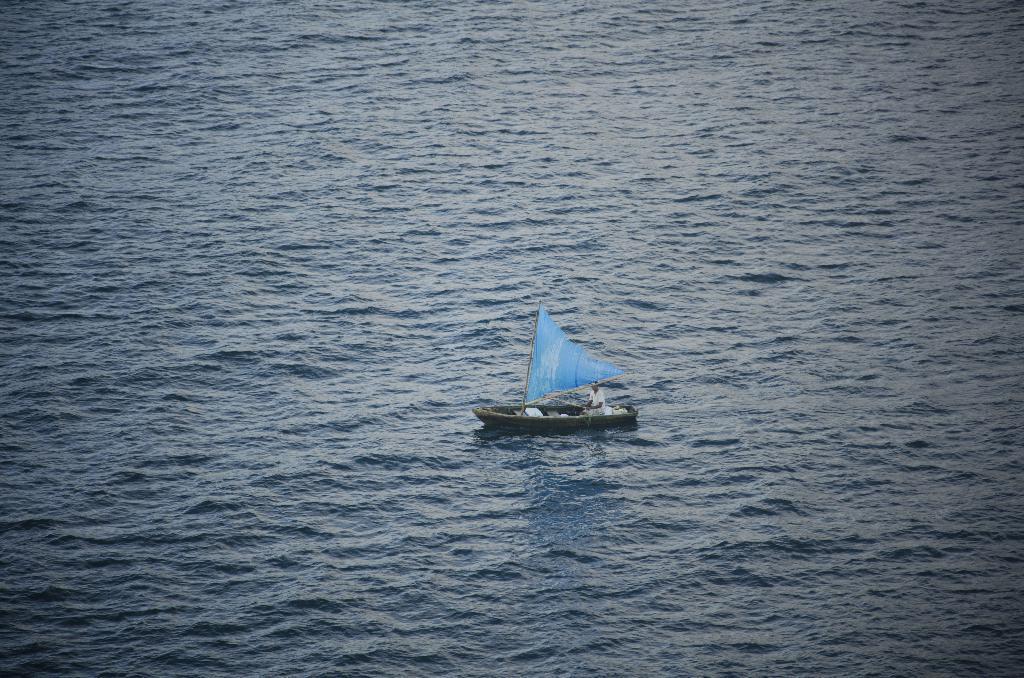Can you describe this image briefly? This picture is clicked outside the city. In the center there is a person in the boat and we can see a blue color cloth seems to be attached to the boat and we can see the water body. 